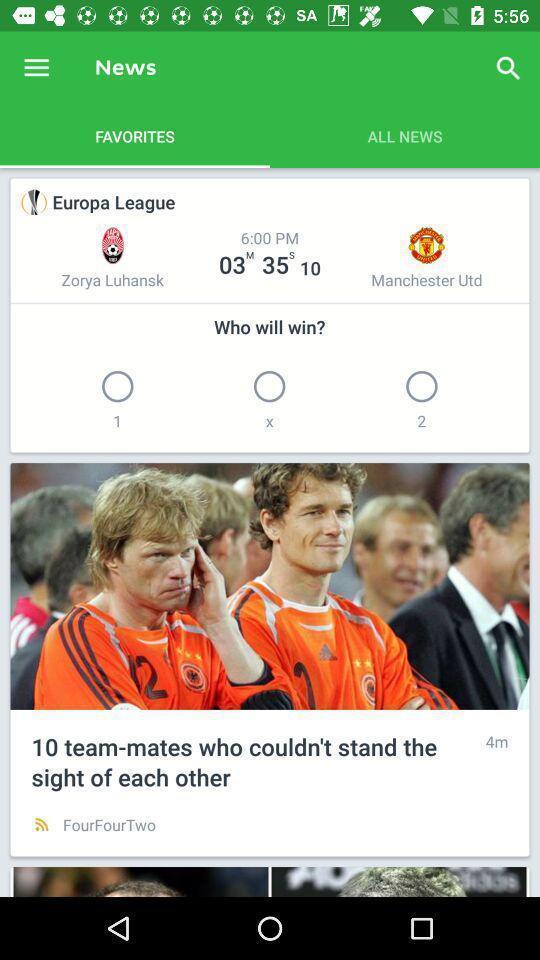Describe this image in words. Page showing info for a soccer scores tracking app. 